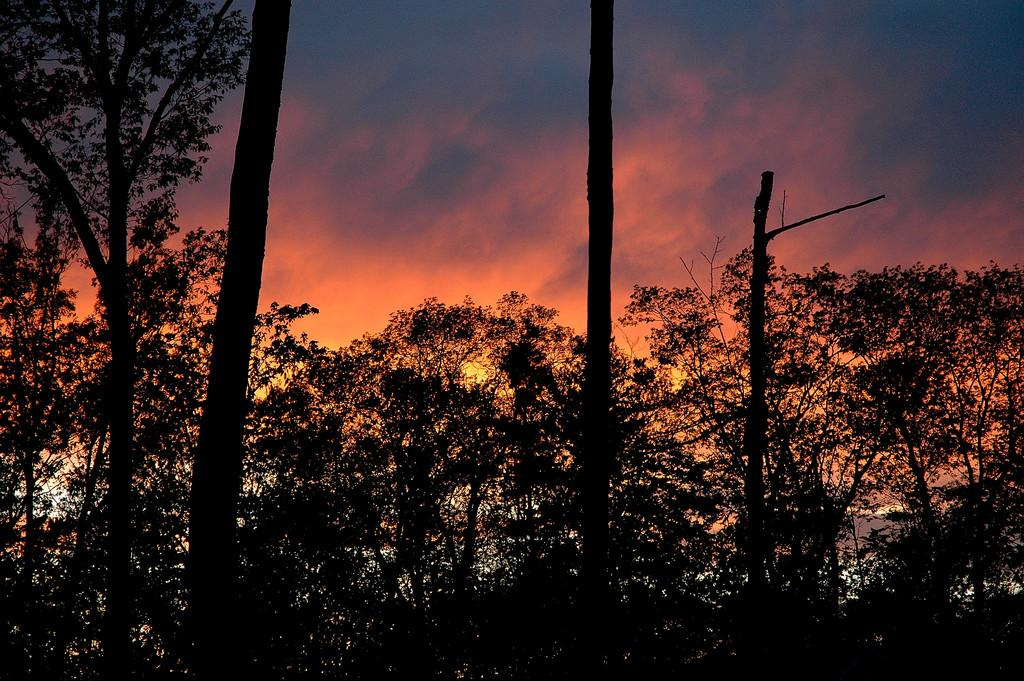What is the primary feature of the landscape in the image? There are many trees in the image. What time of day is depicted in the image? The image depicts a sunset. What type of straw is being used to drive the disease away in the image? There is no straw or disease present in the image; it only features trees and a sunset. 